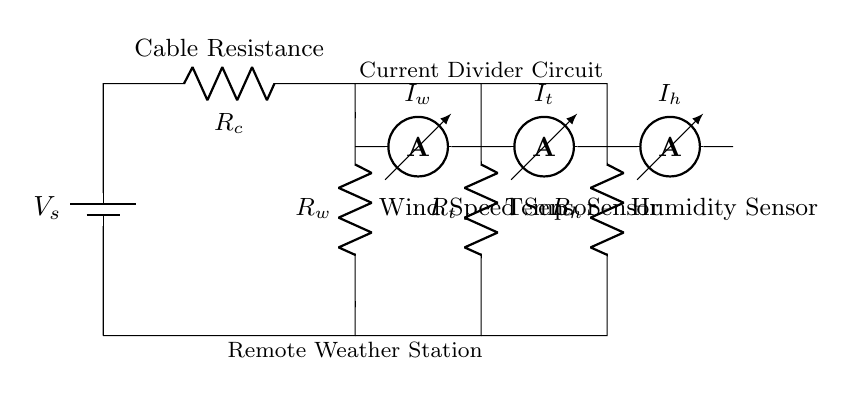What is the total resistance in this circuit? The total resistance can be found by identifying the individual resistances in the circuit. Here, there are three resistors: the cable resistance, the wind speed sensor, and the combination of the temperature and humidity sensors. The specific values are not detailed in the diagram, but the total resistance is the sum of all these resistances.
Answer: Total resistance What is the current through the wind speed sensor? The current through the wind speed sensor can be labeled as I_w in the circuit. This current is part of the current coming from the battery source and depends on the total resistance and voltage.
Answer: I_w How many sensors are present in this circuit? The circuit diagram shows that there are three sensors: the wind speed sensor, the temperature sensor, and the humidity sensor.
Answer: Three What type of circuit is this? The circuit drawn is a current divider circuit, where current from a single source is divided among several branches--in this case, the sensors.
Answer: Current divider What does the ammeter measure in this circuit? The ammeter in each branch measures the current flowing through that particular sensor. For instance, the ammeter labeled I_w measures the current flowing through the wind speed sensor.
Answer: Current Which sensor has the highest resistance? Based on the configuration and standard characteristics, we cannot determine this from the circuit alone without specific resistance values. However, if we assume typical values, we could evaluate them based on known specifications.
Answer: Indeterminate What is the voltage source in this circuit? The voltage source is labeled V_s, and it provides the electrical energy needed for the circuit's operation. Its exact value is not mentioned in the diagram, but it represents the supply voltage for the sensors.
Answer: V_s 